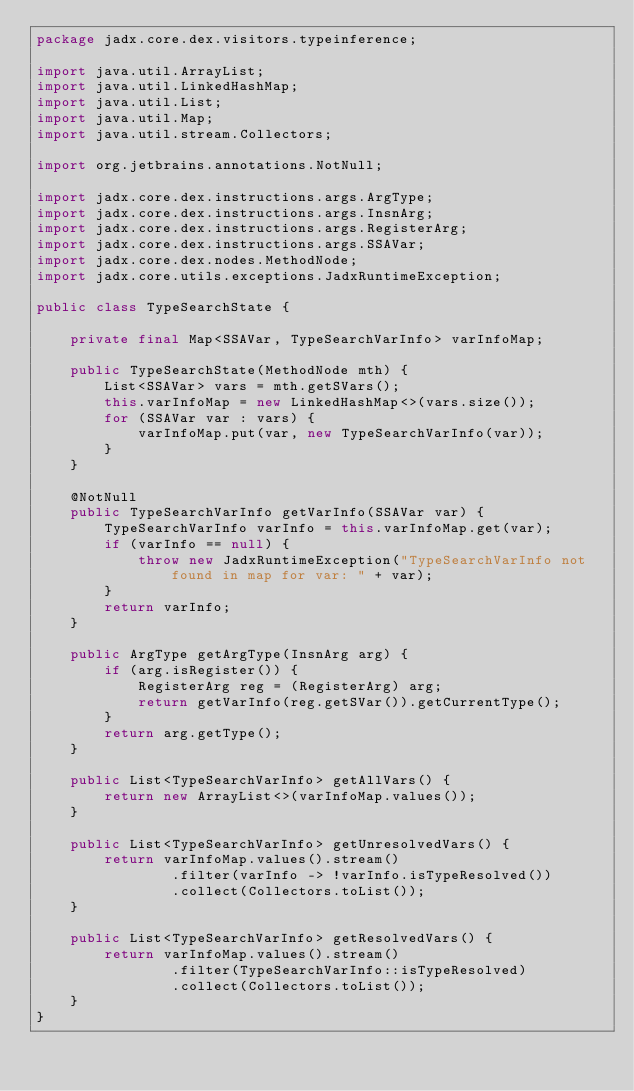Convert code to text. <code><loc_0><loc_0><loc_500><loc_500><_Java_>package jadx.core.dex.visitors.typeinference;

import java.util.ArrayList;
import java.util.LinkedHashMap;
import java.util.List;
import java.util.Map;
import java.util.stream.Collectors;

import org.jetbrains.annotations.NotNull;

import jadx.core.dex.instructions.args.ArgType;
import jadx.core.dex.instructions.args.InsnArg;
import jadx.core.dex.instructions.args.RegisterArg;
import jadx.core.dex.instructions.args.SSAVar;
import jadx.core.dex.nodes.MethodNode;
import jadx.core.utils.exceptions.JadxRuntimeException;

public class TypeSearchState {

	private final Map<SSAVar, TypeSearchVarInfo> varInfoMap;

	public TypeSearchState(MethodNode mth) {
		List<SSAVar> vars = mth.getSVars();
		this.varInfoMap = new LinkedHashMap<>(vars.size());
		for (SSAVar var : vars) {
			varInfoMap.put(var, new TypeSearchVarInfo(var));
		}
	}

	@NotNull
	public TypeSearchVarInfo getVarInfo(SSAVar var) {
		TypeSearchVarInfo varInfo = this.varInfoMap.get(var);
		if (varInfo == null) {
			throw new JadxRuntimeException("TypeSearchVarInfo not found in map for var: " + var);
		}
		return varInfo;
	}

	public ArgType getArgType(InsnArg arg) {
		if (arg.isRegister()) {
			RegisterArg reg = (RegisterArg) arg;
			return getVarInfo(reg.getSVar()).getCurrentType();
		}
		return arg.getType();
	}

	public List<TypeSearchVarInfo> getAllVars() {
		return new ArrayList<>(varInfoMap.values());
	}

	public List<TypeSearchVarInfo> getUnresolvedVars() {
		return varInfoMap.values().stream()
				.filter(varInfo -> !varInfo.isTypeResolved())
				.collect(Collectors.toList());
	}

	public List<TypeSearchVarInfo> getResolvedVars() {
		return varInfoMap.values().stream()
				.filter(TypeSearchVarInfo::isTypeResolved)
				.collect(Collectors.toList());
	}
}
</code> 